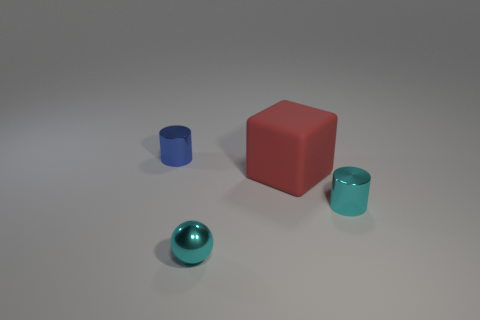Add 4 blue things. How many objects exist? 8 Subtract all cubes. How many objects are left? 3 Add 4 metal things. How many metal things are left? 7 Add 3 cubes. How many cubes exist? 4 Subtract 1 red blocks. How many objects are left? 3 Subtract all tiny metallic cylinders. Subtract all big red objects. How many objects are left? 1 